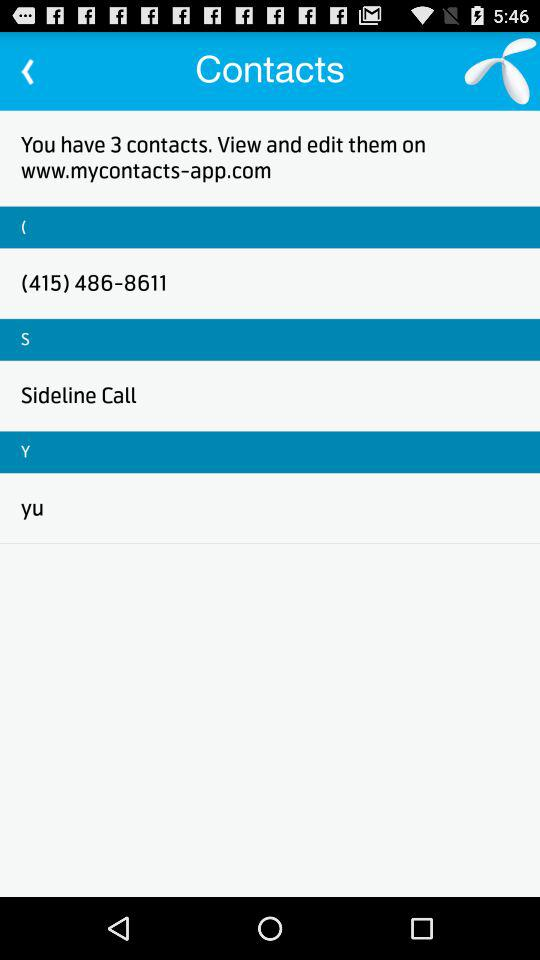How many contacts are there? There are 3 contacts. 